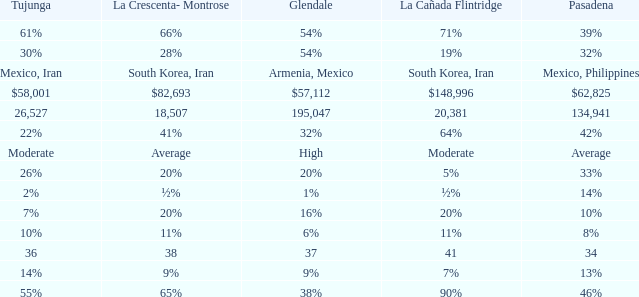What is the percentage of La Canada Flintridge when Tujunga is 7%? 20%. 